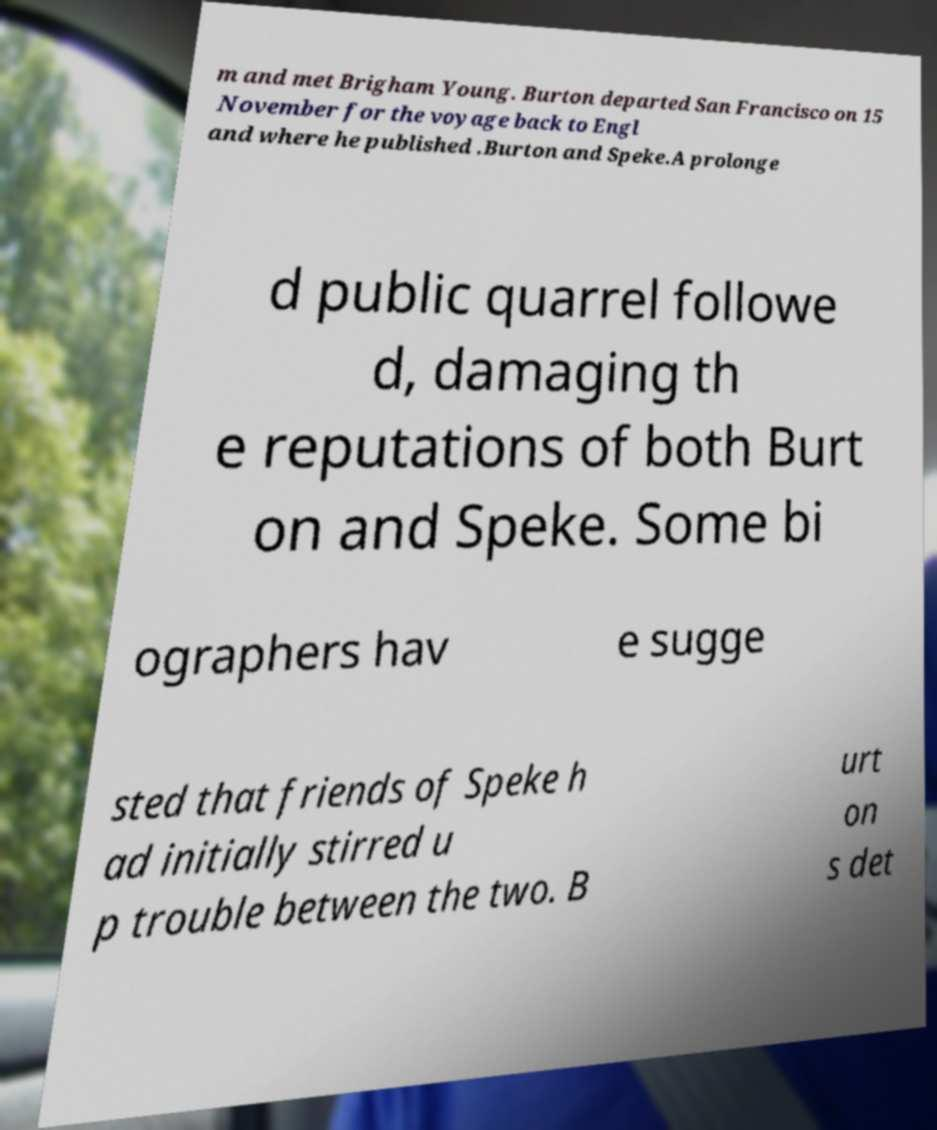Please read and relay the text visible in this image. What does it say? m and met Brigham Young. Burton departed San Francisco on 15 November for the voyage back to Engl and where he published .Burton and Speke.A prolonge d public quarrel followe d, damaging th e reputations of both Burt on and Speke. Some bi ographers hav e sugge sted that friends of Speke h ad initially stirred u p trouble between the two. B urt on s det 